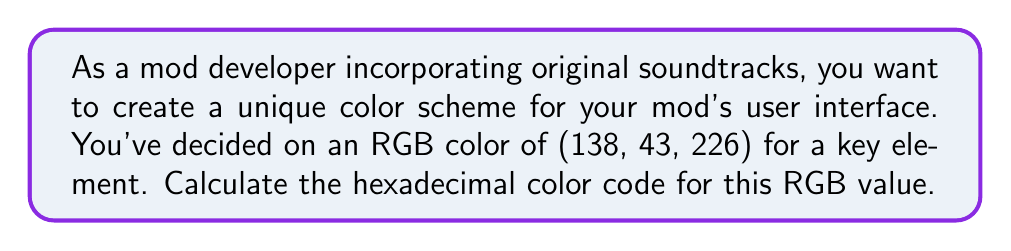Help me with this question. To convert an RGB color to a hexadecimal color code, we need to follow these steps:

1. Convert each RGB value to hexadecimal:
   
   For R (138):
   $138 \div 16 = 8$ remainder $10$
   $8$ in hexadecimal is $8$, and $10$ in hexadecimal is $A$
   So, $138$ in hexadecimal is $8A$

   For G (43):
   $43 \div 16 = 2$ remainder $11$
   $2$ in hexadecimal is $2$, and $11$ in hexadecimal is $B$
   So, $43$ in hexadecimal is $2B$

   For B (226):
   $226 \div 16 = 14$ remainder $2$
   $14$ in hexadecimal is $E$, and $2$ in hexadecimal is $2$
   So, $226$ in hexadecimal is $E2$

2. Combine the hexadecimal values in the order R, G, B:

   $8A2BE2$

3. Add a "#" symbol at the beginning to denote it as a hexadecimal color code:

   $\#8A2BE2$

This process can be represented mathematically as:

$$\text{Hex} = \#\left(\lfloor\frac{R}{16}\rfloor\cdot16+R\bmod16\right)\left(\lfloor\frac{G}{16}\rfloor\cdot16+G\bmod16\right)\left(\lfloor\frac{B}{16}\rfloor\cdot16+B\bmod16\right)$$

Where $\lfloor x \rfloor$ represents the floor function (integer part of $x$), and the result of each parenthesis is converted to its hexadecimal representation.
Answer: $\#8A2BE2$ 